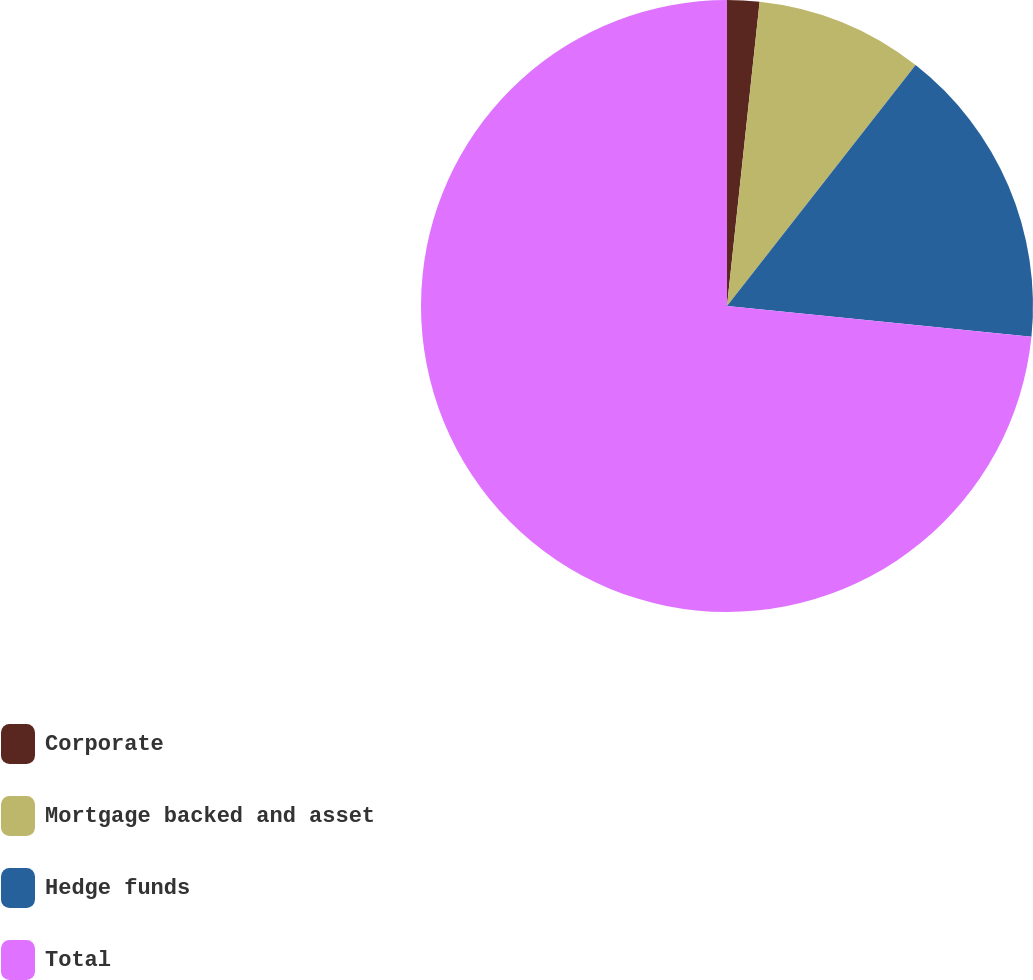Convert chart to OTSL. <chart><loc_0><loc_0><loc_500><loc_500><pie_chart><fcel>Corporate<fcel>Mortgage backed and asset<fcel>Hedge funds<fcel>Total<nl><fcel>1.7%<fcel>8.87%<fcel>16.04%<fcel>73.4%<nl></chart> 